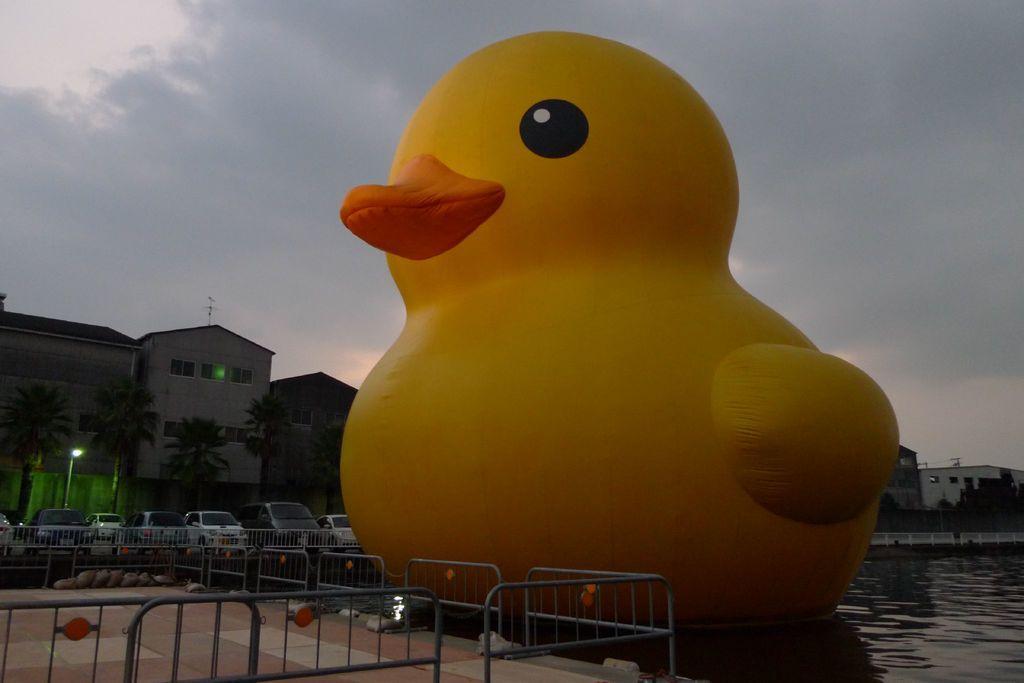Can you describe this image briefly? This image consists of a duck in yellow color. At the bottom, there is water. To the left there is a fencing. In the background, there are cars and buildings. 